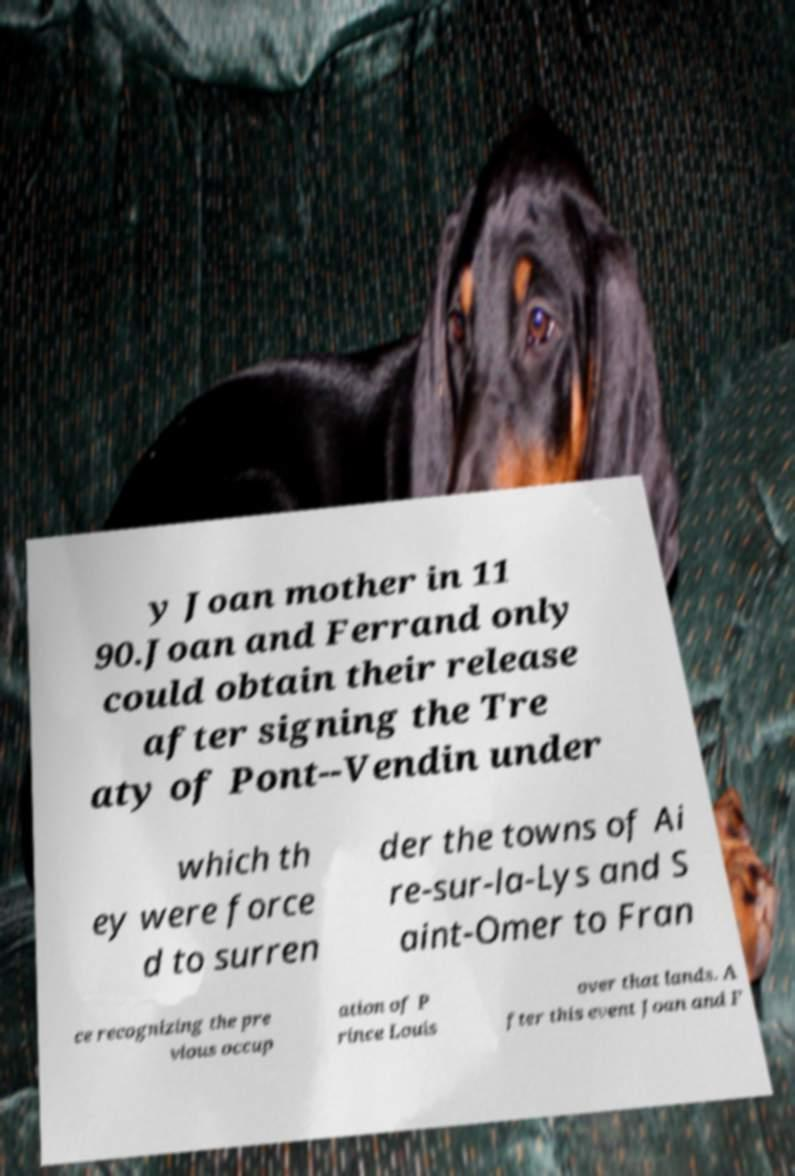Can you read and provide the text displayed in the image?This photo seems to have some interesting text. Can you extract and type it out for me? y Joan mother in 11 90.Joan and Ferrand only could obtain their release after signing the Tre aty of Pont--Vendin under which th ey were force d to surren der the towns of Ai re-sur-la-Lys and S aint-Omer to Fran ce recognizing the pre vious occup ation of P rince Louis over that lands. A fter this event Joan and F 